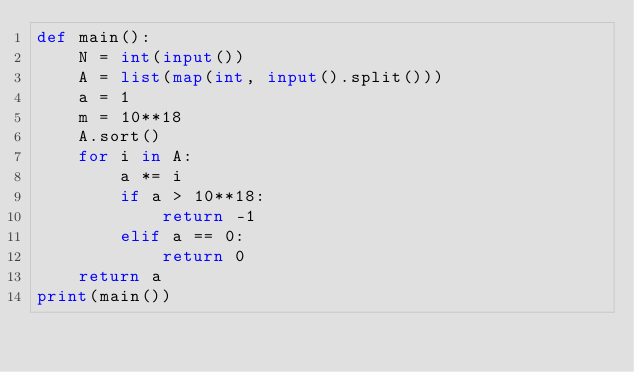Convert code to text. <code><loc_0><loc_0><loc_500><loc_500><_Python_>def main():
    N = int(input())
    A = list(map(int, input().split()))
    a = 1
    m = 10**18
    A.sort()
    for i in A:
        a *= i
        if a > 10**18:
            return -1
        elif a == 0:
            return 0
    return a
print(main())
</code> 